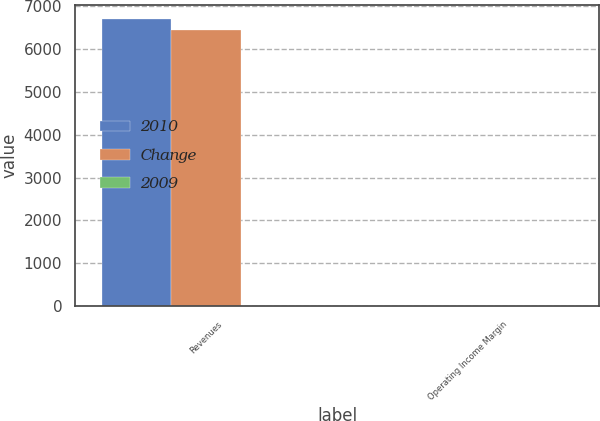Convert chart to OTSL. <chart><loc_0><loc_0><loc_500><loc_500><stacked_bar_chart><ecel><fcel>Revenues<fcel>Operating Income Margin<nl><fcel>2010<fcel>6693<fcel>13.9<nl><fcel>Change<fcel>6426.6<fcel>13.7<nl><fcel>2009<fcel>4<fcel>0.2<nl></chart> 